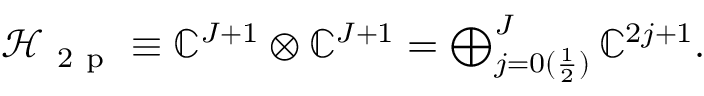Convert formula to latex. <formula><loc_0><loc_0><loc_500><loc_500>\begin{array} { r } { \mathcal { H } _ { 2 p } \equiv \mathbb { C } ^ { J + 1 } \otimes \mathbb { C } ^ { J + 1 } = \bigoplus _ { j = 0 ( \frac { 1 } { 2 } ) } ^ { J } \mathbb { C } ^ { 2 j + 1 } . } \end{array}</formula> 